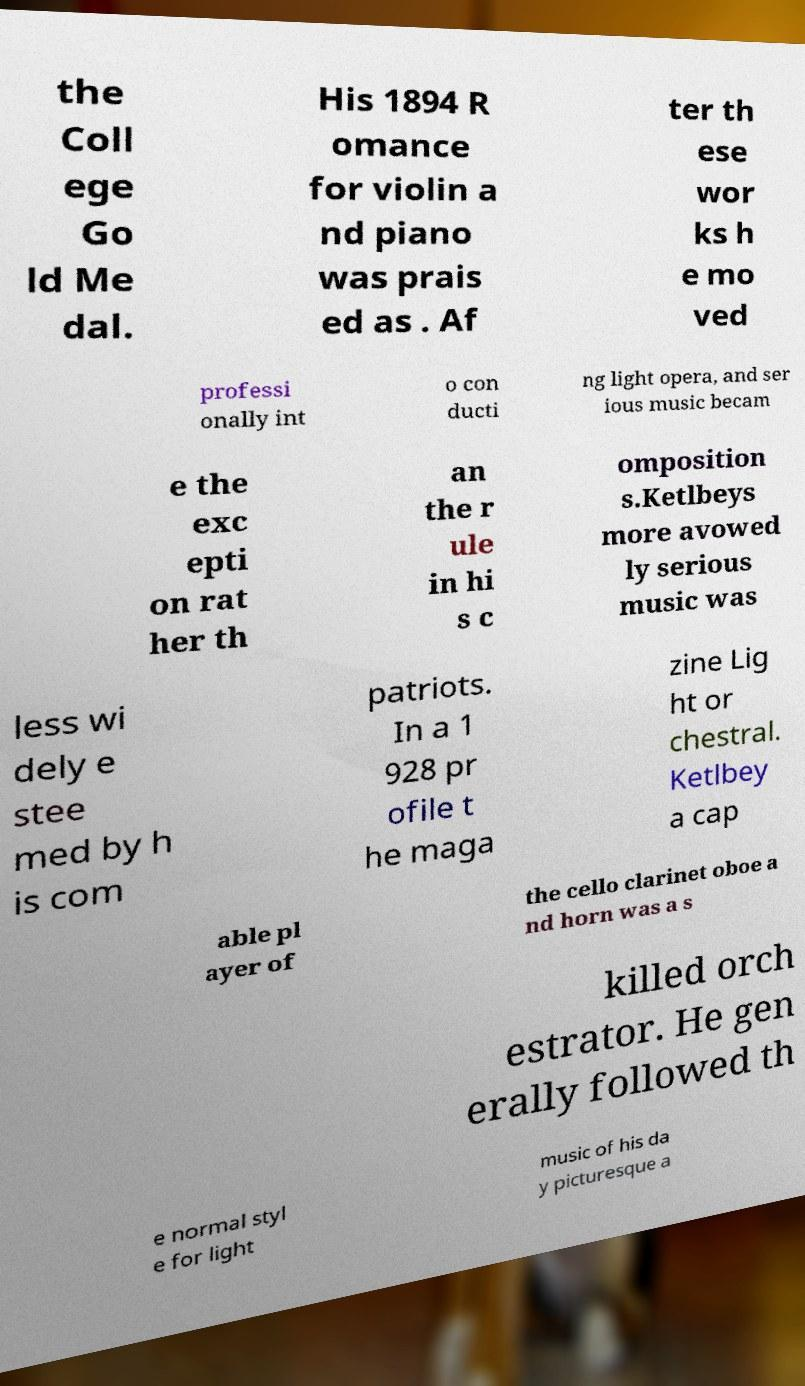Could you extract and type out the text from this image? the Coll ege Go ld Me dal. His 1894 R omance for violin a nd piano was prais ed as . Af ter th ese wor ks h e mo ved professi onally int o con ducti ng light opera, and ser ious music becam e the exc epti on rat her th an the r ule in hi s c omposition s.Ketlbeys more avowed ly serious music was less wi dely e stee med by h is com patriots. In a 1 928 pr ofile t he maga zine Lig ht or chestral. Ketlbey a cap able pl ayer of the cello clarinet oboe a nd horn was a s killed orch estrator. He gen erally followed th e normal styl e for light music of his da y picturesque a 